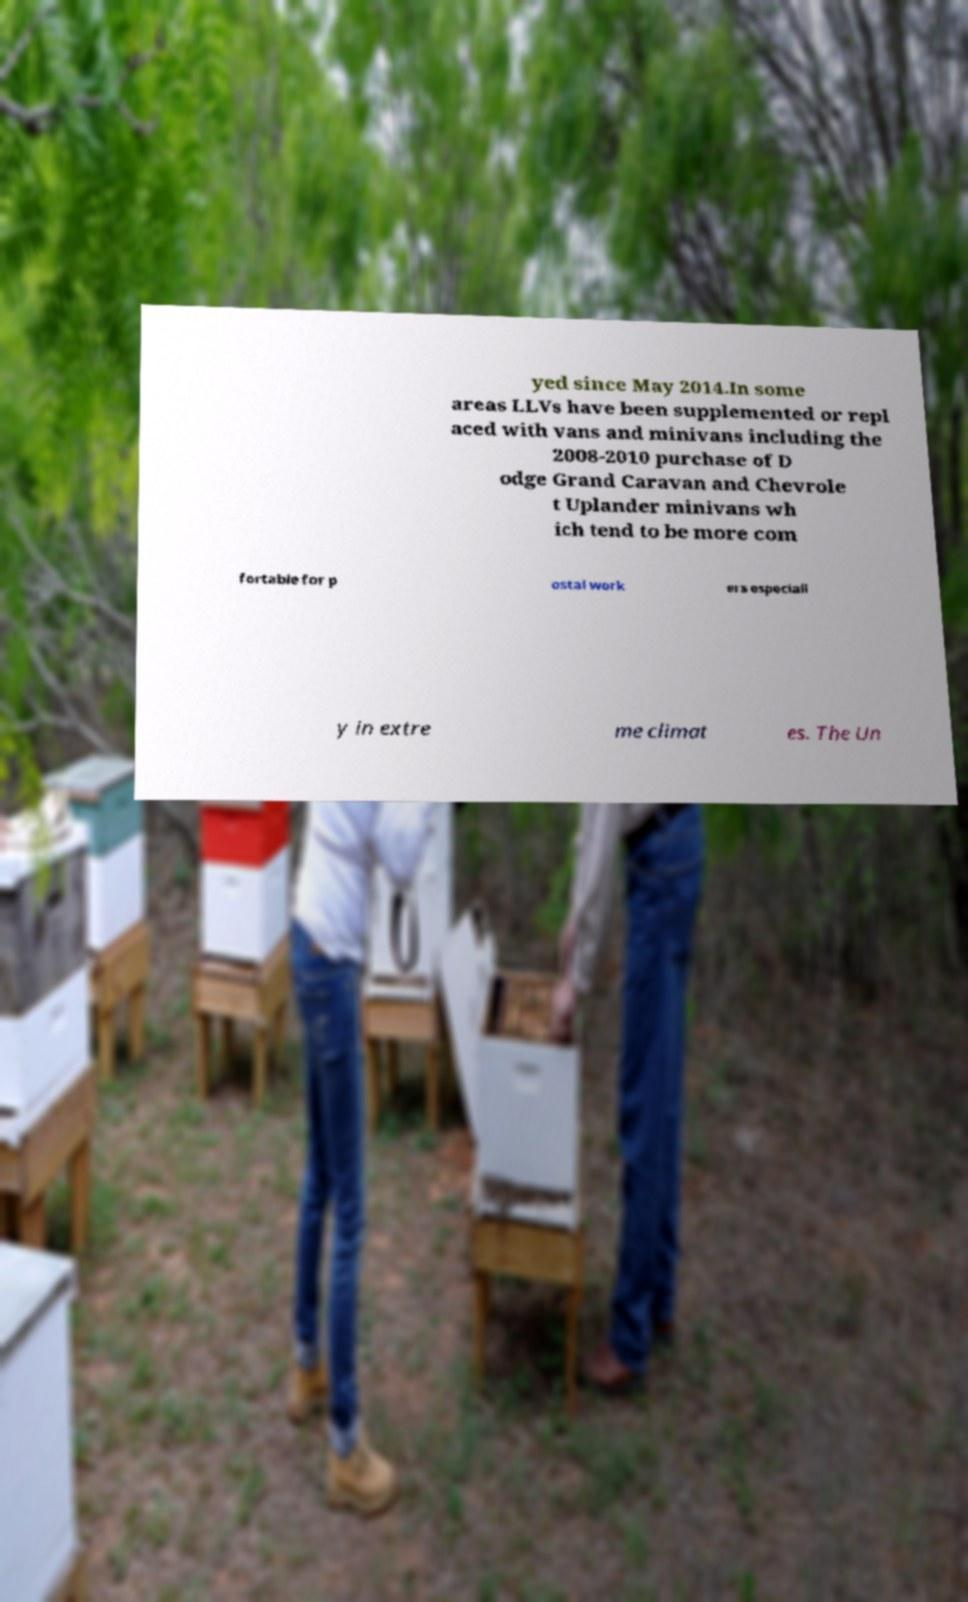Could you extract and type out the text from this image? yed since May 2014.In some areas LLVs have been supplemented or repl aced with vans and minivans including the 2008-2010 purchase of D odge Grand Caravan and Chevrole t Uplander minivans wh ich tend to be more com fortable for p ostal work ers especiall y in extre me climat es. The Un 